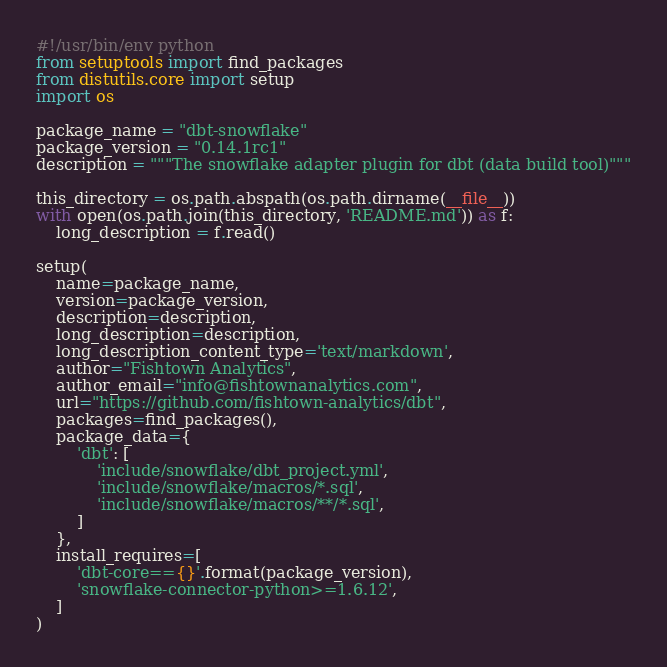<code> <loc_0><loc_0><loc_500><loc_500><_Python_>#!/usr/bin/env python
from setuptools import find_packages
from distutils.core import setup
import os

package_name = "dbt-snowflake"
package_version = "0.14.1rc1"
description = """The snowflake adapter plugin for dbt (data build tool)"""

this_directory = os.path.abspath(os.path.dirname(__file__))
with open(os.path.join(this_directory, 'README.md')) as f:
    long_description = f.read()

setup(
    name=package_name,
    version=package_version,
    description=description,
    long_description=description,
    long_description_content_type='text/markdown',
    author="Fishtown Analytics",
    author_email="info@fishtownanalytics.com",
    url="https://github.com/fishtown-analytics/dbt",
    packages=find_packages(),
    package_data={
        'dbt': [
            'include/snowflake/dbt_project.yml',
            'include/snowflake/macros/*.sql',
            'include/snowflake/macros/**/*.sql',
        ]
    },
    install_requires=[
        'dbt-core=={}'.format(package_version),
        'snowflake-connector-python>=1.6.12',
    ]
)
</code> 